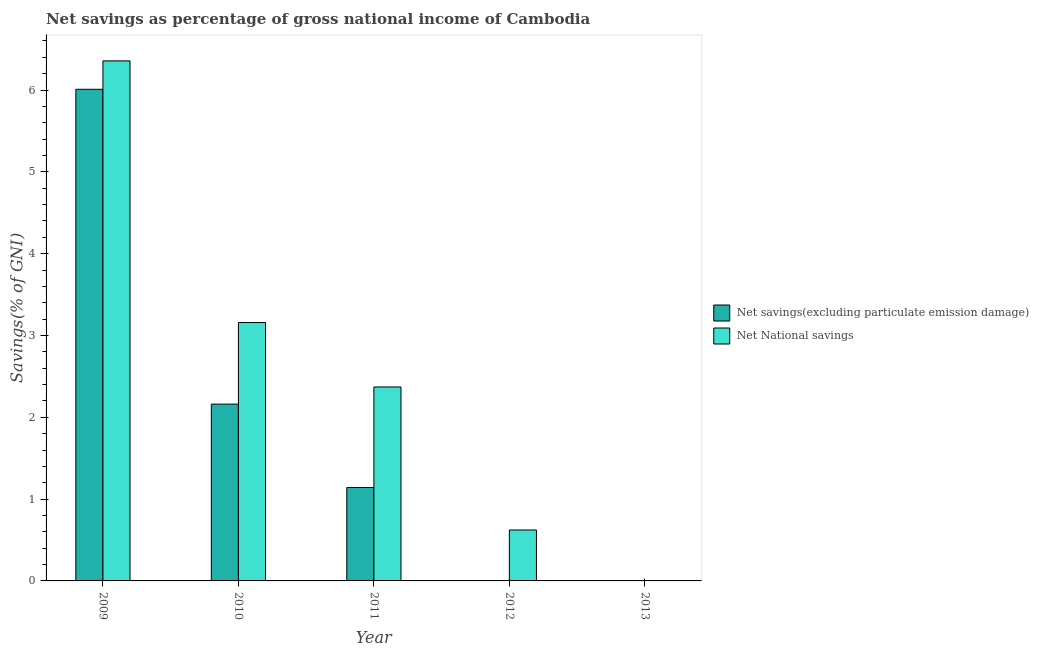Are the number of bars per tick equal to the number of legend labels?
Give a very brief answer. No. How many bars are there on the 5th tick from the left?
Offer a terse response. 0. How many bars are there on the 4th tick from the right?
Make the answer very short. 2. In how many cases, is the number of bars for a given year not equal to the number of legend labels?
Keep it short and to the point. 2. What is the net national savings in 2012?
Your answer should be very brief. 0.62. Across all years, what is the maximum net savings(excluding particulate emission damage)?
Your response must be concise. 6.01. Across all years, what is the minimum net savings(excluding particulate emission damage)?
Your answer should be very brief. 0. In which year was the net national savings maximum?
Your response must be concise. 2009. What is the total net savings(excluding particulate emission damage) in the graph?
Make the answer very short. 9.31. What is the difference between the net national savings in 2009 and that in 2010?
Offer a very short reply. 3.2. What is the difference between the net savings(excluding particulate emission damage) in 2009 and the net national savings in 2012?
Ensure brevity in your answer.  6.01. What is the average net savings(excluding particulate emission damage) per year?
Offer a terse response. 1.86. In the year 2011, what is the difference between the net national savings and net savings(excluding particulate emission damage)?
Keep it short and to the point. 0. What is the ratio of the net savings(excluding particulate emission damage) in 2009 to that in 2010?
Provide a short and direct response. 2.78. Is the net national savings in 2009 less than that in 2010?
Your answer should be compact. No. Is the difference between the net savings(excluding particulate emission damage) in 2009 and 2011 greater than the difference between the net national savings in 2009 and 2011?
Provide a short and direct response. No. What is the difference between the highest and the second highest net national savings?
Offer a terse response. 3.2. What is the difference between the highest and the lowest net savings(excluding particulate emission damage)?
Your response must be concise. 6.01. Is the sum of the net national savings in 2010 and 2012 greater than the maximum net savings(excluding particulate emission damage) across all years?
Your answer should be compact. No. How many bars are there?
Keep it short and to the point. 7. Are the values on the major ticks of Y-axis written in scientific E-notation?
Give a very brief answer. No. How many legend labels are there?
Make the answer very short. 2. How are the legend labels stacked?
Provide a succinct answer. Vertical. What is the title of the graph?
Provide a short and direct response. Net savings as percentage of gross national income of Cambodia. Does "Methane" appear as one of the legend labels in the graph?
Offer a terse response. No. What is the label or title of the Y-axis?
Provide a succinct answer. Savings(% of GNI). What is the Savings(% of GNI) in Net savings(excluding particulate emission damage) in 2009?
Your answer should be compact. 6.01. What is the Savings(% of GNI) of Net National savings in 2009?
Keep it short and to the point. 6.36. What is the Savings(% of GNI) in Net savings(excluding particulate emission damage) in 2010?
Ensure brevity in your answer.  2.16. What is the Savings(% of GNI) of Net National savings in 2010?
Offer a very short reply. 3.16. What is the Savings(% of GNI) of Net savings(excluding particulate emission damage) in 2011?
Offer a terse response. 1.14. What is the Savings(% of GNI) of Net National savings in 2011?
Make the answer very short. 2.37. What is the Savings(% of GNI) in Net savings(excluding particulate emission damage) in 2012?
Your answer should be very brief. 0. What is the Savings(% of GNI) in Net National savings in 2012?
Make the answer very short. 0.62. What is the Savings(% of GNI) of Net savings(excluding particulate emission damage) in 2013?
Ensure brevity in your answer.  0. Across all years, what is the maximum Savings(% of GNI) in Net savings(excluding particulate emission damage)?
Keep it short and to the point. 6.01. Across all years, what is the maximum Savings(% of GNI) in Net National savings?
Offer a terse response. 6.36. Across all years, what is the minimum Savings(% of GNI) in Net savings(excluding particulate emission damage)?
Your response must be concise. 0. What is the total Savings(% of GNI) in Net savings(excluding particulate emission damage) in the graph?
Provide a short and direct response. 9.31. What is the total Savings(% of GNI) of Net National savings in the graph?
Your answer should be very brief. 12.51. What is the difference between the Savings(% of GNI) in Net savings(excluding particulate emission damage) in 2009 and that in 2010?
Give a very brief answer. 3.85. What is the difference between the Savings(% of GNI) in Net National savings in 2009 and that in 2010?
Keep it short and to the point. 3.2. What is the difference between the Savings(% of GNI) in Net savings(excluding particulate emission damage) in 2009 and that in 2011?
Offer a very short reply. 4.87. What is the difference between the Savings(% of GNI) in Net National savings in 2009 and that in 2011?
Make the answer very short. 3.99. What is the difference between the Savings(% of GNI) of Net National savings in 2009 and that in 2012?
Your response must be concise. 5.73. What is the difference between the Savings(% of GNI) of Net savings(excluding particulate emission damage) in 2010 and that in 2011?
Provide a succinct answer. 1.02. What is the difference between the Savings(% of GNI) of Net National savings in 2010 and that in 2011?
Keep it short and to the point. 0.79. What is the difference between the Savings(% of GNI) in Net National savings in 2010 and that in 2012?
Provide a short and direct response. 2.54. What is the difference between the Savings(% of GNI) of Net National savings in 2011 and that in 2012?
Make the answer very short. 1.75. What is the difference between the Savings(% of GNI) of Net savings(excluding particulate emission damage) in 2009 and the Savings(% of GNI) of Net National savings in 2010?
Give a very brief answer. 2.85. What is the difference between the Savings(% of GNI) of Net savings(excluding particulate emission damage) in 2009 and the Savings(% of GNI) of Net National savings in 2011?
Provide a succinct answer. 3.64. What is the difference between the Savings(% of GNI) in Net savings(excluding particulate emission damage) in 2009 and the Savings(% of GNI) in Net National savings in 2012?
Give a very brief answer. 5.39. What is the difference between the Savings(% of GNI) of Net savings(excluding particulate emission damage) in 2010 and the Savings(% of GNI) of Net National savings in 2011?
Provide a short and direct response. -0.21. What is the difference between the Savings(% of GNI) of Net savings(excluding particulate emission damage) in 2010 and the Savings(% of GNI) of Net National savings in 2012?
Your answer should be compact. 1.54. What is the difference between the Savings(% of GNI) of Net savings(excluding particulate emission damage) in 2011 and the Savings(% of GNI) of Net National savings in 2012?
Provide a succinct answer. 0.52. What is the average Savings(% of GNI) in Net savings(excluding particulate emission damage) per year?
Your answer should be very brief. 1.86. What is the average Savings(% of GNI) of Net National savings per year?
Keep it short and to the point. 2.5. In the year 2009, what is the difference between the Savings(% of GNI) in Net savings(excluding particulate emission damage) and Savings(% of GNI) in Net National savings?
Provide a succinct answer. -0.35. In the year 2010, what is the difference between the Savings(% of GNI) of Net savings(excluding particulate emission damage) and Savings(% of GNI) of Net National savings?
Your answer should be very brief. -1. In the year 2011, what is the difference between the Savings(% of GNI) of Net savings(excluding particulate emission damage) and Savings(% of GNI) of Net National savings?
Give a very brief answer. -1.23. What is the ratio of the Savings(% of GNI) in Net savings(excluding particulate emission damage) in 2009 to that in 2010?
Your answer should be compact. 2.78. What is the ratio of the Savings(% of GNI) in Net National savings in 2009 to that in 2010?
Your answer should be very brief. 2.01. What is the ratio of the Savings(% of GNI) of Net savings(excluding particulate emission damage) in 2009 to that in 2011?
Your answer should be very brief. 5.26. What is the ratio of the Savings(% of GNI) of Net National savings in 2009 to that in 2011?
Provide a short and direct response. 2.68. What is the ratio of the Savings(% of GNI) in Net National savings in 2009 to that in 2012?
Keep it short and to the point. 10.21. What is the ratio of the Savings(% of GNI) of Net savings(excluding particulate emission damage) in 2010 to that in 2011?
Provide a short and direct response. 1.89. What is the ratio of the Savings(% of GNI) in Net National savings in 2010 to that in 2011?
Provide a succinct answer. 1.33. What is the ratio of the Savings(% of GNI) of Net National savings in 2010 to that in 2012?
Offer a terse response. 5.07. What is the ratio of the Savings(% of GNI) of Net National savings in 2011 to that in 2012?
Your answer should be compact. 3.81. What is the difference between the highest and the second highest Savings(% of GNI) in Net savings(excluding particulate emission damage)?
Offer a very short reply. 3.85. What is the difference between the highest and the second highest Savings(% of GNI) of Net National savings?
Your answer should be very brief. 3.2. What is the difference between the highest and the lowest Savings(% of GNI) of Net savings(excluding particulate emission damage)?
Your answer should be compact. 6.01. What is the difference between the highest and the lowest Savings(% of GNI) of Net National savings?
Your response must be concise. 6.36. 